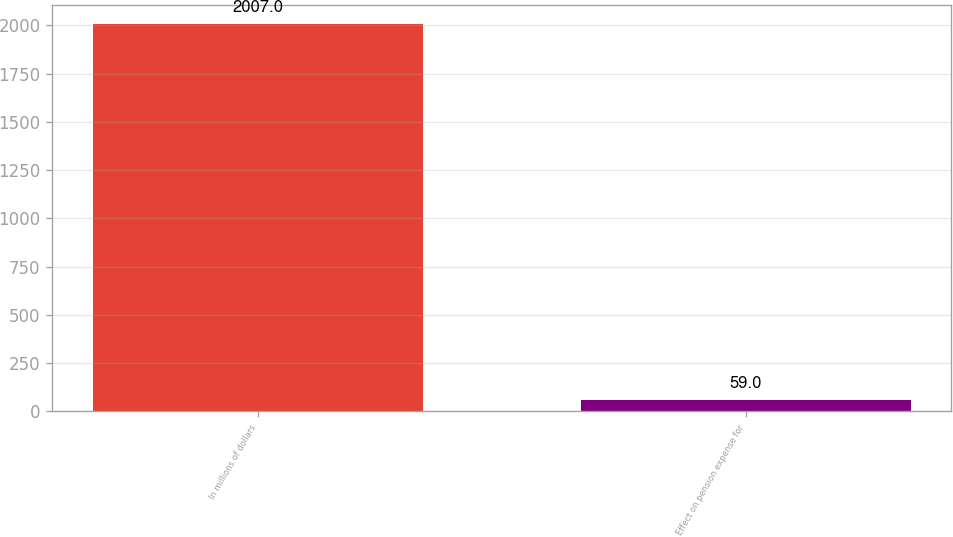Convert chart to OTSL. <chart><loc_0><loc_0><loc_500><loc_500><bar_chart><fcel>In millions of dollars<fcel>Effect on pension expense for<nl><fcel>2007<fcel>59<nl></chart> 